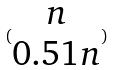<formula> <loc_0><loc_0><loc_500><loc_500>( \begin{matrix} n \\ 0 . 5 1 n \end{matrix} )</formula> 